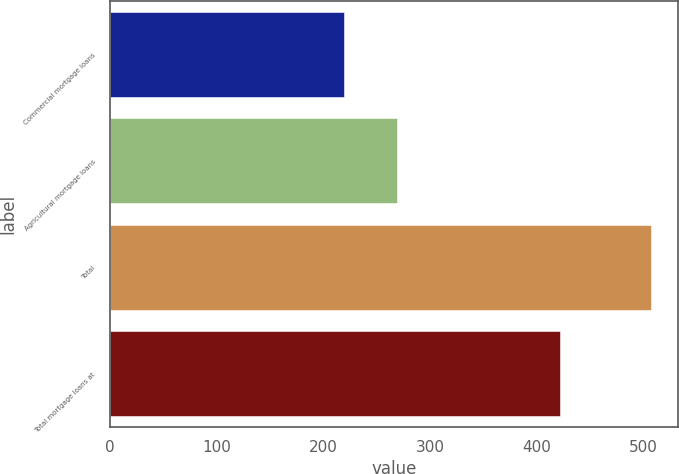Convert chart. <chart><loc_0><loc_0><loc_500><loc_500><bar_chart><fcel>Commercial mortgage loans<fcel>Agricultural mortgage loans<fcel>Total<fcel>Total mortgage loans at<nl><fcel>219<fcel>269<fcel>507<fcel>422<nl></chart> 